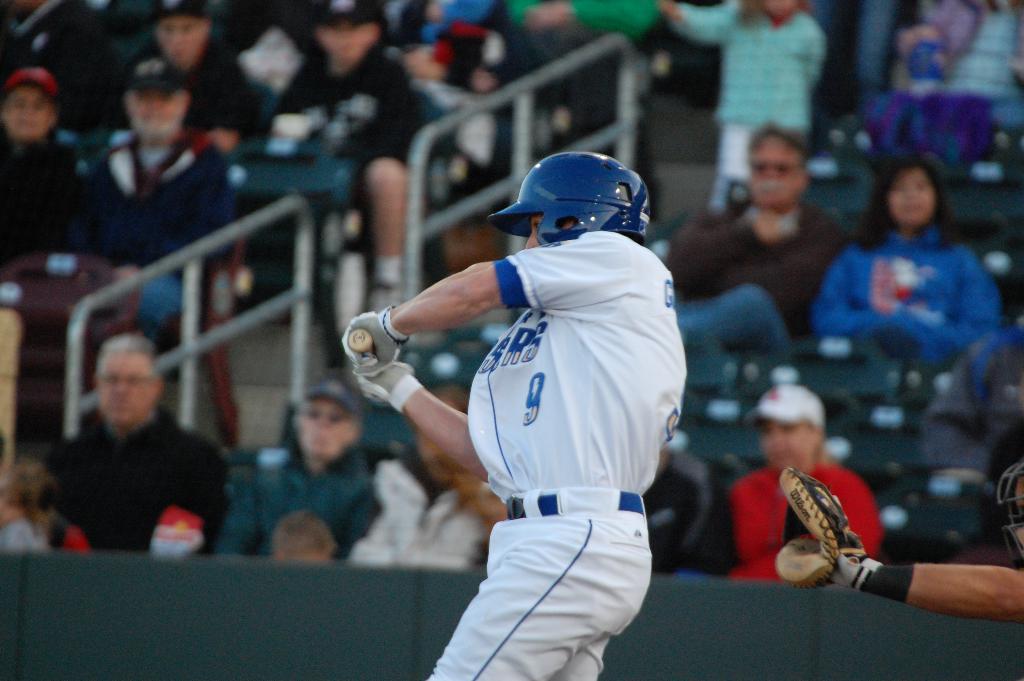What is the player's number?
Give a very brief answer. 9. 